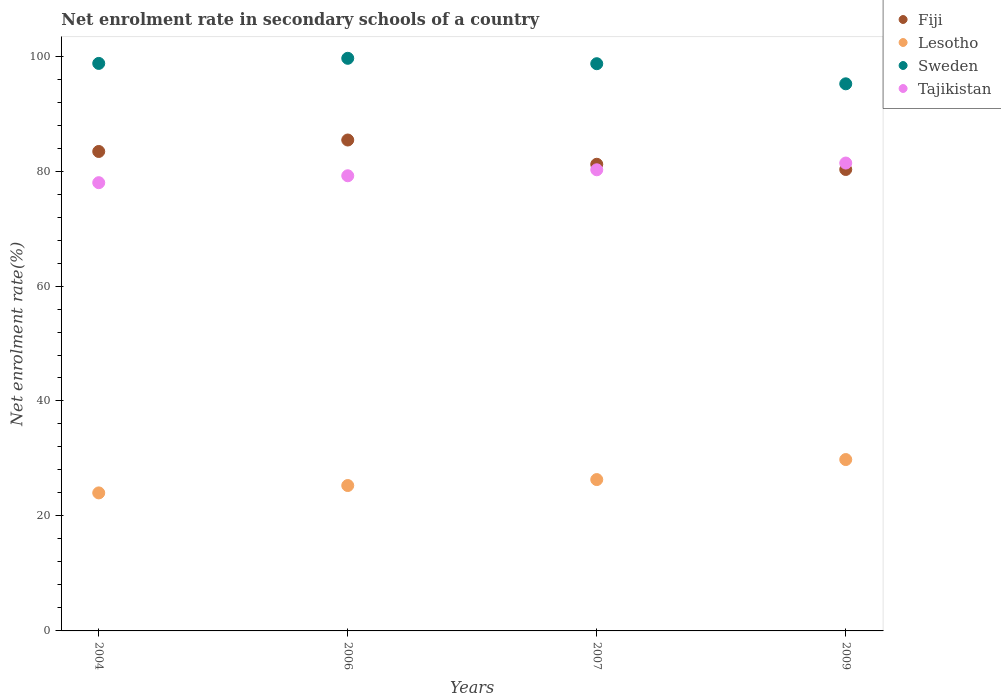Is the number of dotlines equal to the number of legend labels?
Provide a short and direct response. Yes. What is the net enrolment rate in secondary schools in Fiji in 2006?
Keep it short and to the point. 85.4. Across all years, what is the maximum net enrolment rate in secondary schools in Lesotho?
Give a very brief answer. 29.81. Across all years, what is the minimum net enrolment rate in secondary schools in Sweden?
Your answer should be compact. 95.18. What is the total net enrolment rate in secondary schools in Fiji in the graph?
Offer a very short reply. 330.26. What is the difference between the net enrolment rate in secondary schools in Tajikistan in 2007 and that in 2009?
Keep it short and to the point. -1.17. What is the difference between the net enrolment rate in secondary schools in Fiji in 2009 and the net enrolment rate in secondary schools in Tajikistan in 2007?
Provide a short and direct response. 0.05. What is the average net enrolment rate in secondary schools in Sweden per year?
Make the answer very short. 98.05. In the year 2009, what is the difference between the net enrolment rate in secondary schools in Tajikistan and net enrolment rate in secondary schools in Lesotho?
Keep it short and to the point. 51.58. What is the ratio of the net enrolment rate in secondary schools in Fiji in 2007 to that in 2009?
Make the answer very short. 1.01. Is the net enrolment rate in secondary schools in Lesotho in 2006 less than that in 2009?
Offer a terse response. Yes. What is the difference between the highest and the second highest net enrolment rate in secondary schools in Tajikistan?
Your answer should be compact. 1.17. What is the difference between the highest and the lowest net enrolment rate in secondary schools in Sweden?
Give a very brief answer. 4.44. Is the sum of the net enrolment rate in secondary schools in Tajikistan in 2004 and 2006 greater than the maximum net enrolment rate in secondary schools in Lesotho across all years?
Offer a very short reply. Yes. Is it the case that in every year, the sum of the net enrolment rate in secondary schools in Sweden and net enrolment rate in secondary schools in Tajikistan  is greater than the net enrolment rate in secondary schools in Fiji?
Keep it short and to the point. Yes. Does the net enrolment rate in secondary schools in Fiji monotonically increase over the years?
Your response must be concise. No. How many years are there in the graph?
Offer a very short reply. 4. Does the graph contain any zero values?
Offer a terse response. No. Where does the legend appear in the graph?
Your response must be concise. Top right. How many legend labels are there?
Make the answer very short. 4. What is the title of the graph?
Make the answer very short. Net enrolment rate in secondary schools of a country. What is the label or title of the X-axis?
Provide a succinct answer. Years. What is the label or title of the Y-axis?
Your response must be concise. Net enrolment rate(%). What is the Net enrolment rate(%) in Fiji in 2004?
Provide a short and direct response. 83.41. What is the Net enrolment rate(%) in Lesotho in 2004?
Ensure brevity in your answer.  24.01. What is the Net enrolment rate(%) of Sweden in 2004?
Ensure brevity in your answer.  98.73. What is the Net enrolment rate(%) of Tajikistan in 2004?
Offer a terse response. 77.98. What is the Net enrolment rate(%) of Fiji in 2006?
Provide a short and direct response. 85.4. What is the Net enrolment rate(%) in Lesotho in 2006?
Give a very brief answer. 25.29. What is the Net enrolment rate(%) in Sweden in 2006?
Offer a very short reply. 99.61. What is the Net enrolment rate(%) in Tajikistan in 2006?
Provide a short and direct response. 79.18. What is the Net enrolment rate(%) of Fiji in 2007?
Give a very brief answer. 81.18. What is the Net enrolment rate(%) in Lesotho in 2007?
Your answer should be compact. 26.33. What is the Net enrolment rate(%) in Sweden in 2007?
Your answer should be very brief. 98.68. What is the Net enrolment rate(%) of Tajikistan in 2007?
Offer a very short reply. 80.22. What is the Net enrolment rate(%) of Fiji in 2009?
Give a very brief answer. 80.27. What is the Net enrolment rate(%) of Lesotho in 2009?
Your answer should be compact. 29.81. What is the Net enrolment rate(%) in Sweden in 2009?
Ensure brevity in your answer.  95.18. What is the Net enrolment rate(%) in Tajikistan in 2009?
Give a very brief answer. 81.39. Across all years, what is the maximum Net enrolment rate(%) in Fiji?
Provide a succinct answer. 85.4. Across all years, what is the maximum Net enrolment rate(%) of Lesotho?
Keep it short and to the point. 29.81. Across all years, what is the maximum Net enrolment rate(%) of Sweden?
Your response must be concise. 99.61. Across all years, what is the maximum Net enrolment rate(%) of Tajikistan?
Your answer should be very brief. 81.39. Across all years, what is the minimum Net enrolment rate(%) in Fiji?
Provide a succinct answer. 80.27. Across all years, what is the minimum Net enrolment rate(%) of Lesotho?
Your response must be concise. 24.01. Across all years, what is the minimum Net enrolment rate(%) of Sweden?
Your response must be concise. 95.18. Across all years, what is the minimum Net enrolment rate(%) in Tajikistan?
Keep it short and to the point. 77.98. What is the total Net enrolment rate(%) of Fiji in the graph?
Offer a terse response. 330.26. What is the total Net enrolment rate(%) of Lesotho in the graph?
Make the answer very short. 105.44. What is the total Net enrolment rate(%) in Sweden in the graph?
Ensure brevity in your answer.  392.19. What is the total Net enrolment rate(%) of Tajikistan in the graph?
Offer a very short reply. 318.78. What is the difference between the Net enrolment rate(%) of Fiji in 2004 and that in 2006?
Your answer should be compact. -1.99. What is the difference between the Net enrolment rate(%) in Lesotho in 2004 and that in 2006?
Give a very brief answer. -1.28. What is the difference between the Net enrolment rate(%) in Sweden in 2004 and that in 2006?
Give a very brief answer. -0.89. What is the difference between the Net enrolment rate(%) of Tajikistan in 2004 and that in 2006?
Your response must be concise. -1.2. What is the difference between the Net enrolment rate(%) of Fiji in 2004 and that in 2007?
Ensure brevity in your answer.  2.23. What is the difference between the Net enrolment rate(%) in Lesotho in 2004 and that in 2007?
Offer a terse response. -2.32. What is the difference between the Net enrolment rate(%) of Sweden in 2004 and that in 2007?
Your answer should be compact. 0.05. What is the difference between the Net enrolment rate(%) in Tajikistan in 2004 and that in 2007?
Offer a very short reply. -2.24. What is the difference between the Net enrolment rate(%) in Fiji in 2004 and that in 2009?
Offer a terse response. 3.13. What is the difference between the Net enrolment rate(%) of Lesotho in 2004 and that in 2009?
Provide a short and direct response. -5.8. What is the difference between the Net enrolment rate(%) of Sweden in 2004 and that in 2009?
Make the answer very short. 3.55. What is the difference between the Net enrolment rate(%) in Tajikistan in 2004 and that in 2009?
Give a very brief answer. -3.42. What is the difference between the Net enrolment rate(%) in Fiji in 2006 and that in 2007?
Give a very brief answer. 4.22. What is the difference between the Net enrolment rate(%) of Lesotho in 2006 and that in 2007?
Your response must be concise. -1.04. What is the difference between the Net enrolment rate(%) of Sweden in 2006 and that in 2007?
Provide a short and direct response. 0.94. What is the difference between the Net enrolment rate(%) in Tajikistan in 2006 and that in 2007?
Your answer should be very brief. -1.04. What is the difference between the Net enrolment rate(%) in Fiji in 2006 and that in 2009?
Provide a succinct answer. 5.13. What is the difference between the Net enrolment rate(%) in Lesotho in 2006 and that in 2009?
Give a very brief answer. -4.52. What is the difference between the Net enrolment rate(%) in Sweden in 2006 and that in 2009?
Keep it short and to the point. 4.44. What is the difference between the Net enrolment rate(%) of Tajikistan in 2006 and that in 2009?
Keep it short and to the point. -2.21. What is the difference between the Net enrolment rate(%) in Fiji in 2007 and that in 2009?
Keep it short and to the point. 0.91. What is the difference between the Net enrolment rate(%) in Lesotho in 2007 and that in 2009?
Your answer should be compact. -3.48. What is the difference between the Net enrolment rate(%) of Sweden in 2007 and that in 2009?
Give a very brief answer. 3.5. What is the difference between the Net enrolment rate(%) of Tajikistan in 2007 and that in 2009?
Give a very brief answer. -1.17. What is the difference between the Net enrolment rate(%) of Fiji in 2004 and the Net enrolment rate(%) of Lesotho in 2006?
Offer a terse response. 58.11. What is the difference between the Net enrolment rate(%) of Fiji in 2004 and the Net enrolment rate(%) of Sweden in 2006?
Your answer should be compact. -16.21. What is the difference between the Net enrolment rate(%) in Fiji in 2004 and the Net enrolment rate(%) in Tajikistan in 2006?
Your response must be concise. 4.23. What is the difference between the Net enrolment rate(%) in Lesotho in 2004 and the Net enrolment rate(%) in Sweden in 2006?
Ensure brevity in your answer.  -75.6. What is the difference between the Net enrolment rate(%) in Lesotho in 2004 and the Net enrolment rate(%) in Tajikistan in 2006?
Offer a very short reply. -55.17. What is the difference between the Net enrolment rate(%) in Sweden in 2004 and the Net enrolment rate(%) in Tajikistan in 2006?
Make the answer very short. 19.54. What is the difference between the Net enrolment rate(%) in Fiji in 2004 and the Net enrolment rate(%) in Lesotho in 2007?
Keep it short and to the point. 57.08. What is the difference between the Net enrolment rate(%) in Fiji in 2004 and the Net enrolment rate(%) in Sweden in 2007?
Your answer should be compact. -15.27. What is the difference between the Net enrolment rate(%) in Fiji in 2004 and the Net enrolment rate(%) in Tajikistan in 2007?
Ensure brevity in your answer.  3.19. What is the difference between the Net enrolment rate(%) in Lesotho in 2004 and the Net enrolment rate(%) in Sweden in 2007?
Ensure brevity in your answer.  -74.66. What is the difference between the Net enrolment rate(%) in Lesotho in 2004 and the Net enrolment rate(%) in Tajikistan in 2007?
Ensure brevity in your answer.  -56.21. What is the difference between the Net enrolment rate(%) in Sweden in 2004 and the Net enrolment rate(%) in Tajikistan in 2007?
Your answer should be compact. 18.5. What is the difference between the Net enrolment rate(%) in Fiji in 2004 and the Net enrolment rate(%) in Lesotho in 2009?
Make the answer very short. 53.59. What is the difference between the Net enrolment rate(%) of Fiji in 2004 and the Net enrolment rate(%) of Sweden in 2009?
Your answer should be very brief. -11.77. What is the difference between the Net enrolment rate(%) of Fiji in 2004 and the Net enrolment rate(%) of Tajikistan in 2009?
Keep it short and to the point. 2.01. What is the difference between the Net enrolment rate(%) in Lesotho in 2004 and the Net enrolment rate(%) in Sweden in 2009?
Make the answer very short. -71.17. What is the difference between the Net enrolment rate(%) in Lesotho in 2004 and the Net enrolment rate(%) in Tajikistan in 2009?
Offer a very short reply. -57.38. What is the difference between the Net enrolment rate(%) of Sweden in 2004 and the Net enrolment rate(%) of Tajikistan in 2009?
Provide a succinct answer. 17.33. What is the difference between the Net enrolment rate(%) of Fiji in 2006 and the Net enrolment rate(%) of Lesotho in 2007?
Your answer should be very brief. 59.07. What is the difference between the Net enrolment rate(%) in Fiji in 2006 and the Net enrolment rate(%) in Sweden in 2007?
Give a very brief answer. -13.27. What is the difference between the Net enrolment rate(%) in Fiji in 2006 and the Net enrolment rate(%) in Tajikistan in 2007?
Offer a terse response. 5.18. What is the difference between the Net enrolment rate(%) of Lesotho in 2006 and the Net enrolment rate(%) of Sweden in 2007?
Offer a terse response. -73.38. What is the difference between the Net enrolment rate(%) of Lesotho in 2006 and the Net enrolment rate(%) of Tajikistan in 2007?
Make the answer very short. -54.93. What is the difference between the Net enrolment rate(%) in Sweden in 2006 and the Net enrolment rate(%) in Tajikistan in 2007?
Provide a succinct answer. 19.39. What is the difference between the Net enrolment rate(%) in Fiji in 2006 and the Net enrolment rate(%) in Lesotho in 2009?
Offer a terse response. 55.59. What is the difference between the Net enrolment rate(%) of Fiji in 2006 and the Net enrolment rate(%) of Sweden in 2009?
Your answer should be compact. -9.78. What is the difference between the Net enrolment rate(%) in Fiji in 2006 and the Net enrolment rate(%) in Tajikistan in 2009?
Make the answer very short. 4.01. What is the difference between the Net enrolment rate(%) of Lesotho in 2006 and the Net enrolment rate(%) of Sweden in 2009?
Keep it short and to the point. -69.88. What is the difference between the Net enrolment rate(%) in Lesotho in 2006 and the Net enrolment rate(%) in Tajikistan in 2009?
Ensure brevity in your answer.  -56.1. What is the difference between the Net enrolment rate(%) in Sweden in 2006 and the Net enrolment rate(%) in Tajikistan in 2009?
Ensure brevity in your answer.  18.22. What is the difference between the Net enrolment rate(%) of Fiji in 2007 and the Net enrolment rate(%) of Lesotho in 2009?
Provide a succinct answer. 51.37. What is the difference between the Net enrolment rate(%) in Fiji in 2007 and the Net enrolment rate(%) in Sweden in 2009?
Provide a short and direct response. -14. What is the difference between the Net enrolment rate(%) in Fiji in 2007 and the Net enrolment rate(%) in Tajikistan in 2009?
Your answer should be compact. -0.21. What is the difference between the Net enrolment rate(%) in Lesotho in 2007 and the Net enrolment rate(%) in Sweden in 2009?
Your answer should be very brief. -68.85. What is the difference between the Net enrolment rate(%) of Lesotho in 2007 and the Net enrolment rate(%) of Tajikistan in 2009?
Make the answer very short. -55.07. What is the difference between the Net enrolment rate(%) of Sweden in 2007 and the Net enrolment rate(%) of Tajikistan in 2009?
Your answer should be compact. 17.28. What is the average Net enrolment rate(%) of Fiji per year?
Give a very brief answer. 82.57. What is the average Net enrolment rate(%) in Lesotho per year?
Your response must be concise. 26.36. What is the average Net enrolment rate(%) of Sweden per year?
Provide a short and direct response. 98.05. What is the average Net enrolment rate(%) in Tajikistan per year?
Give a very brief answer. 79.69. In the year 2004, what is the difference between the Net enrolment rate(%) of Fiji and Net enrolment rate(%) of Lesotho?
Ensure brevity in your answer.  59.4. In the year 2004, what is the difference between the Net enrolment rate(%) of Fiji and Net enrolment rate(%) of Sweden?
Provide a succinct answer. -15.32. In the year 2004, what is the difference between the Net enrolment rate(%) in Fiji and Net enrolment rate(%) in Tajikistan?
Your response must be concise. 5.43. In the year 2004, what is the difference between the Net enrolment rate(%) of Lesotho and Net enrolment rate(%) of Sweden?
Provide a succinct answer. -74.72. In the year 2004, what is the difference between the Net enrolment rate(%) in Lesotho and Net enrolment rate(%) in Tajikistan?
Your answer should be very brief. -53.97. In the year 2004, what is the difference between the Net enrolment rate(%) of Sweden and Net enrolment rate(%) of Tajikistan?
Your response must be concise. 20.75. In the year 2006, what is the difference between the Net enrolment rate(%) of Fiji and Net enrolment rate(%) of Lesotho?
Make the answer very short. 60.11. In the year 2006, what is the difference between the Net enrolment rate(%) in Fiji and Net enrolment rate(%) in Sweden?
Make the answer very short. -14.21. In the year 2006, what is the difference between the Net enrolment rate(%) of Fiji and Net enrolment rate(%) of Tajikistan?
Your response must be concise. 6.22. In the year 2006, what is the difference between the Net enrolment rate(%) in Lesotho and Net enrolment rate(%) in Sweden?
Your response must be concise. -74.32. In the year 2006, what is the difference between the Net enrolment rate(%) in Lesotho and Net enrolment rate(%) in Tajikistan?
Ensure brevity in your answer.  -53.89. In the year 2006, what is the difference between the Net enrolment rate(%) of Sweden and Net enrolment rate(%) of Tajikistan?
Your answer should be compact. 20.43. In the year 2007, what is the difference between the Net enrolment rate(%) of Fiji and Net enrolment rate(%) of Lesotho?
Provide a short and direct response. 54.85. In the year 2007, what is the difference between the Net enrolment rate(%) in Fiji and Net enrolment rate(%) in Sweden?
Give a very brief answer. -17.5. In the year 2007, what is the difference between the Net enrolment rate(%) in Fiji and Net enrolment rate(%) in Tajikistan?
Provide a succinct answer. 0.96. In the year 2007, what is the difference between the Net enrolment rate(%) of Lesotho and Net enrolment rate(%) of Sweden?
Keep it short and to the point. -72.35. In the year 2007, what is the difference between the Net enrolment rate(%) of Lesotho and Net enrolment rate(%) of Tajikistan?
Your answer should be very brief. -53.89. In the year 2007, what is the difference between the Net enrolment rate(%) in Sweden and Net enrolment rate(%) in Tajikistan?
Offer a terse response. 18.45. In the year 2009, what is the difference between the Net enrolment rate(%) of Fiji and Net enrolment rate(%) of Lesotho?
Your answer should be compact. 50.46. In the year 2009, what is the difference between the Net enrolment rate(%) of Fiji and Net enrolment rate(%) of Sweden?
Keep it short and to the point. -14.9. In the year 2009, what is the difference between the Net enrolment rate(%) in Fiji and Net enrolment rate(%) in Tajikistan?
Provide a short and direct response. -1.12. In the year 2009, what is the difference between the Net enrolment rate(%) in Lesotho and Net enrolment rate(%) in Sweden?
Provide a short and direct response. -65.36. In the year 2009, what is the difference between the Net enrolment rate(%) of Lesotho and Net enrolment rate(%) of Tajikistan?
Your answer should be very brief. -51.58. In the year 2009, what is the difference between the Net enrolment rate(%) in Sweden and Net enrolment rate(%) in Tajikistan?
Your answer should be compact. 13.78. What is the ratio of the Net enrolment rate(%) in Fiji in 2004 to that in 2006?
Offer a terse response. 0.98. What is the ratio of the Net enrolment rate(%) of Lesotho in 2004 to that in 2006?
Give a very brief answer. 0.95. What is the ratio of the Net enrolment rate(%) in Tajikistan in 2004 to that in 2006?
Your answer should be very brief. 0.98. What is the ratio of the Net enrolment rate(%) in Fiji in 2004 to that in 2007?
Your response must be concise. 1.03. What is the ratio of the Net enrolment rate(%) in Lesotho in 2004 to that in 2007?
Offer a very short reply. 0.91. What is the ratio of the Net enrolment rate(%) in Fiji in 2004 to that in 2009?
Your answer should be compact. 1.04. What is the ratio of the Net enrolment rate(%) of Lesotho in 2004 to that in 2009?
Your answer should be compact. 0.81. What is the ratio of the Net enrolment rate(%) of Sweden in 2004 to that in 2009?
Provide a short and direct response. 1.04. What is the ratio of the Net enrolment rate(%) in Tajikistan in 2004 to that in 2009?
Provide a short and direct response. 0.96. What is the ratio of the Net enrolment rate(%) of Fiji in 2006 to that in 2007?
Offer a very short reply. 1.05. What is the ratio of the Net enrolment rate(%) in Lesotho in 2006 to that in 2007?
Provide a succinct answer. 0.96. What is the ratio of the Net enrolment rate(%) in Sweden in 2006 to that in 2007?
Provide a short and direct response. 1.01. What is the ratio of the Net enrolment rate(%) in Tajikistan in 2006 to that in 2007?
Make the answer very short. 0.99. What is the ratio of the Net enrolment rate(%) of Fiji in 2006 to that in 2009?
Offer a terse response. 1.06. What is the ratio of the Net enrolment rate(%) of Lesotho in 2006 to that in 2009?
Your answer should be compact. 0.85. What is the ratio of the Net enrolment rate(%) in Sweden in 2006 to that in 2009?
Ensure brevity in your answer.  1.05. What is the ratio of the Net enrolment rate(%) of Tajikistan in 2006 to that in 2009?
Offer a terse response. 0.97. What is the ratio of the Net enrolment rate(%) of Fiji in 2007 to that in 2009?
Offer a very short reply. 1.01. What is the ratio of the Net enrolment rate(%) in Lesotho in 2007 to that in 2009?
Make the answer very short. 0.88. What is the ratio of the Net enrolment rate(%) of Sweden in 2007 to that in 2009?
Provide a short and direct response. 1.04. What is the ratio of the Net enrolment rate(%) in Tajikistan in 2007 to that in 2009?
Keep it short and to the point. 0.99. What is the difference between the highest and the second highest Net enrolment rate(%) in Fiji?
Offer a very short reply. 1.99. What is the difference between the highest and the second highest Net enrolment rate(%) of Lesotho?
Your answer should be very brief. 3.48. What is the difference between the highest and the second highest Net enrolment rate(%) of Sweden?
Offer a very short reply. 0.89. What is the difference between the highest and the second highest Net enrolment rate(%) of Tajikistan?
Provide a short and direct response. 1.17. What is the difference between the highest and the lowest Net enrolment rate(%) in Fiji?
Ensure brevity in your answer.  5.13. What is the difference between the highest and the lowest Net enrolment rate(%) in Lesotho?
Your answer should be very brief. 5.8. What is the difference between the highest and the lowest Net enrolment rate(%) in Sweden?
Provide a succinct answer. 4.44. What is the difference between the highest and the lowest Net enrolment rate(%) of Tajikistan?
Offer a terse response. 3.42. 